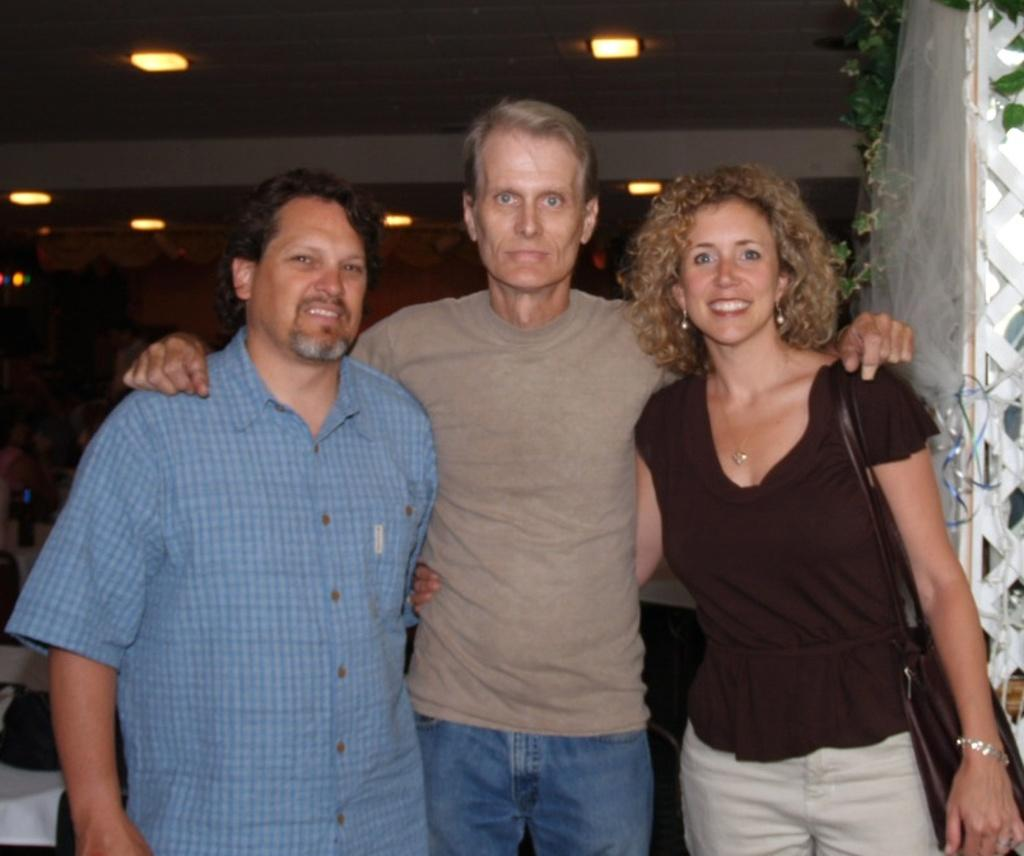How many people are in the image? There is a group of people in the image, but the exact number cannot be determined from the provided facts. What are the people in the image doing? Some people are seated, while others are standing. What can be seen in the background of the image? There are tables, lights, and plants in the background of the image. What type of plant is being plotted in the image? There is no plant being plotted in the image; the provided facts only mention the presence of plants in the background. 